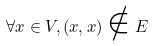<formula> <loc_0><loc_0><loc_500><loc_500>\forall x \in V , ( x , x ) \notin E</formula> 